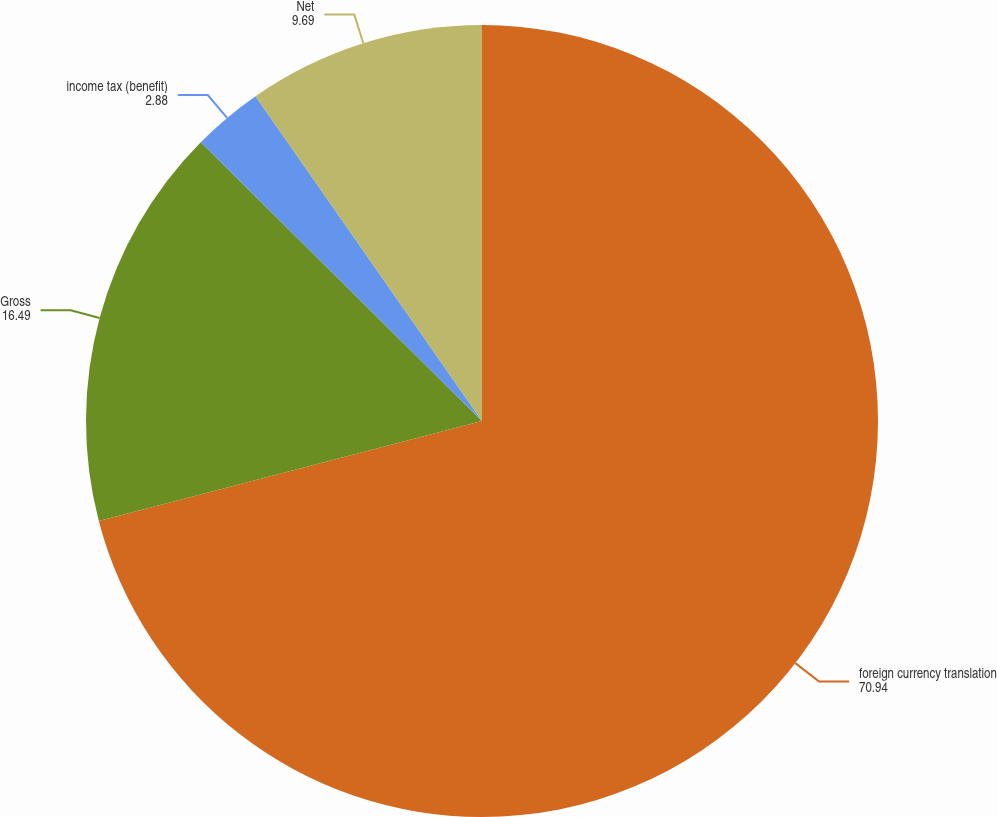<chart> <loc_0><loc_0><loc_500><loc_500><pie_chart><fcel>foreign currency translation<fcel>Gross<fcel>income tax (benefit)<fcel>Net<nl><fcel>70.94%<fcel>16.49%<fcel>2.88%<fcel>9.69%<nl></chart> 